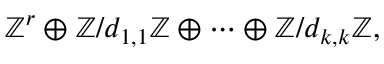Convert formula to latex. <formula><loc_0><loc_0><loc_500><loc_500>\mathbb { Z } ^ { r } \oplus \mathbb { Z } / d _ { 1 , 1 } \mathbb { Z } \oplus \cdots \oplus \mathbb { Z } / d _ { k , k } \mathbb { Z } ,</formula> 